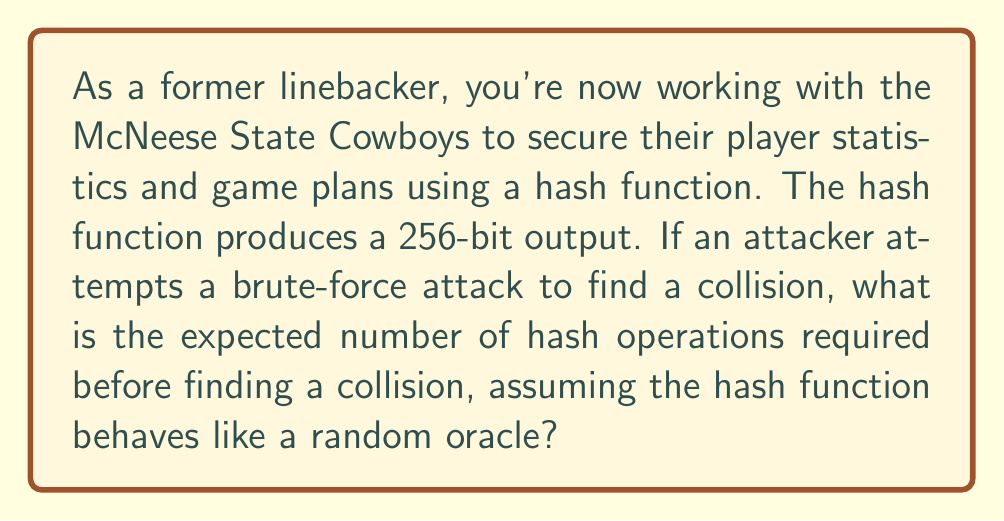Show me your answer to this math problem. To solve this problem, we need to understand the birthday paradox and its application to hash function collisions.

Step 1: Identify the hash function output size
The hash function produces a 256-bit output.

Step 2: Calculate the number of possible hash values
Number of possible hash values = $2^{256}$

Step 3: Apply the birthday paradox approximation
For a hash function with $n$ possible outputs, the expected number of hash operations before finding a collision is approximately $\sqrt{\pi n/2}$.

Step 4: Substitute the values into the formula
Expected number of operations = $\sqrt{\pi \cdot 2^{256} / 2}$

Step 5: Simplify the expression
$$\begin{align}
\text{Expected operations} &= \sqrt{\pi \cdot 2^{255}} \\
&= \sqrt{\pi} \cdot 2^{128} \\
&\approx 1.77 \cdot 2^{128} \\
&\approx 4.8 \cdot 10^{38}
\end{align}$$

This extremely large number of operations indicates that the hash function is very strong against collision attacks, making it suitable for securing player statistics and game plans.
Answer: $4.8 \times 10^{38}$ hash operations 